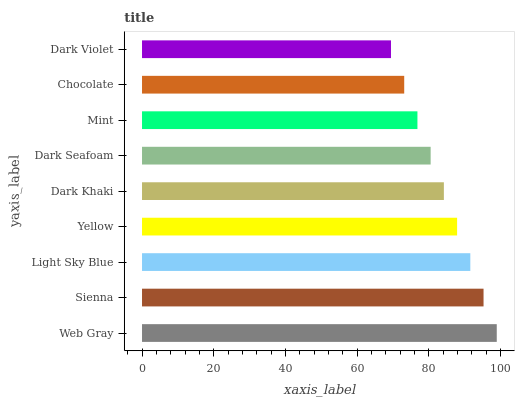Is Dark Violet the minimum?
Answer yes or no. Yes. Is Web Gray the maximum?
Answer yes or no. Yes. Is Sienna the minimum?
Answer yes or no. No. Is Sienna the maximum?
Answer yes or no. No. Is Web Gray greater than Sienna?
Answer yes or no. Yes. Is Sienna less than Web Gray?
Answer yes or no. Yes. Is Sienna greater than Web Gray?
Answer yes or no. No. Is Web Gray less than Sienna?
Answer yes or no. No. Is Dark Khaki the high median?
Answer yes or no. Yes. Is Dark Khaki the low median?
Answer yes or no. Yes. Is Yellow the high median?
Answer yes or no. No. Is Sienna the low median?
Answer yes or no. No. 